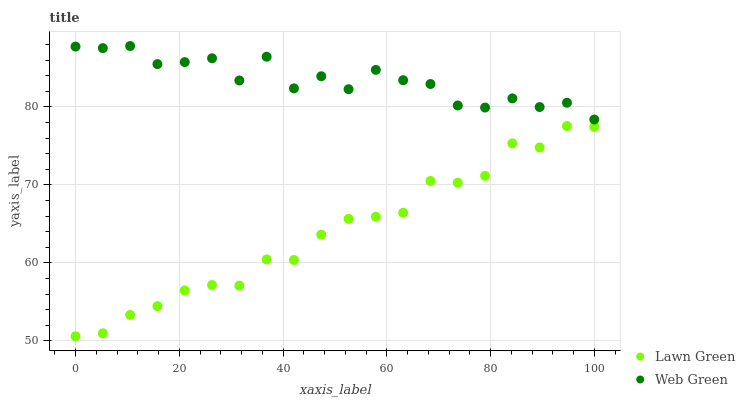Does Lawn Green have the minimum area under the curve?
Answer yes or no. Yes. Does Web Green have the maximum area under the curve?
Answer yes or no. Yes. Does Web Green have the minimum area under the curve?
Answer yes or no. No. Is Lawn Green the smoothest?
Answer yes or no. Yes. Is Web Green the roughest?
Answer yes or no. Yes. Is Web Green the smoothest?
Answer yes or no. No. Does Lawn Green have the lowest value?
Answer yes or no. Yes. Does Web Green have the lowest value?
Answer yes or no. No. Does Web Green have the highest value?
Answer yes or no. Yes. Is Lawn Green less than Web Green?
Answer yes or no. Yes. Is Web Green greater than Lawn Green?
Answer yes or no. Yes. Does Lawn Green intersect Web Green?
Answer yes or no. No. 